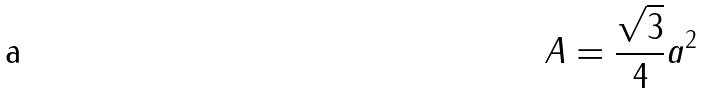<formula> <loc_0><loc_0><loc_500><loc_500>A = \frac { \sqrt { 3 } } { 4 } a ^ { 2 }</formula> 